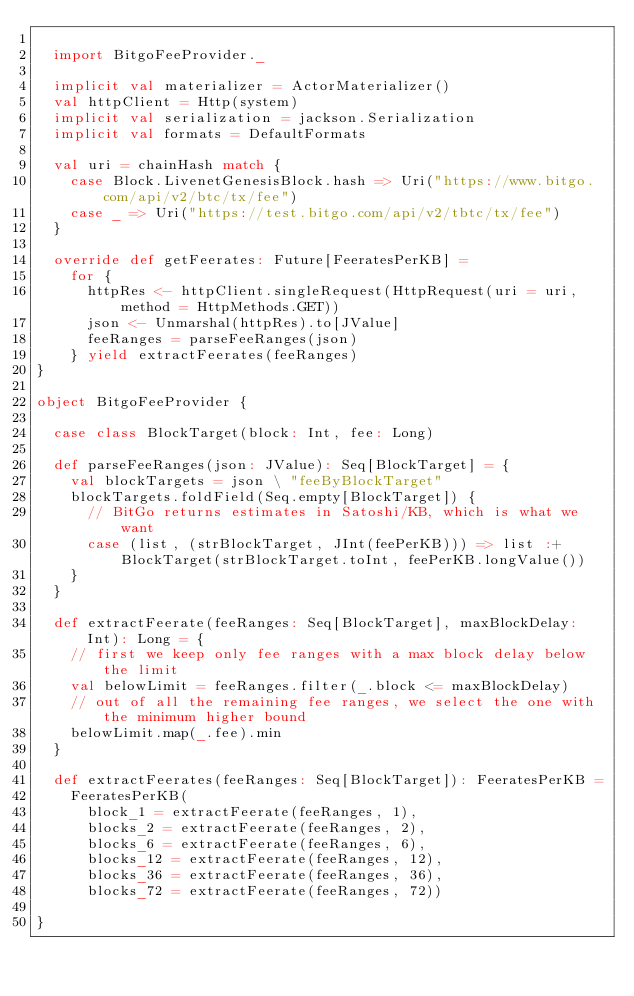<code> <loc_0><loc_0><loc_500><loc_500><_Scala_>
  import BitgoFeeProvider._

  implicit val materializer = ActorMaterializer()
  val httpClient = Http(system)
  implicit val serialization = jackson.Serialization
  implicit val formats = DefaultFormats

  val uri = chainHash match {
    case Block.LivenetGenesisBlock.hash => Uri("https://www.bitgo.com/api/v2/btc/tx/fee")
    case _ => Uri("https://test.bitgo.com/api/v2/tbtc/tx/fee")
  }

  override def getFeerates: Future[FeeratesPerKB] =
    for {
      httpRes <- httpClient.singleRequest(HttpRequest(uri = uri, method = HttpMethods.GET))
      json <- Unmarshal(httpRes).to[JValue]
      feeRanges = parseFeeRanges(json)
    } yield extractFeerates(feeRanges)
}

object BitgoFeeProvider {

  case class BlockTarget(block: Int, fee: Long)

  def parseFeeRanges(json: JValue): Seq[BlockTarget] = {
    val blockTargets = json \ "feeByBlockTarget"
    blockTargets.foldField(Seq.empty[BlockTarget]) {
      // BitGo returns estimates in Satoshi/KB, which is what we want
      case (list, (strBlockTarget, JInt(feePerKB))) => list :+ BlockTarget(strBlockTarget.toInt, feePerKB.longValue())
    }
  }

  def extractFeerate(feeRanges: Seq[BlockTarget], maxBlockDelay: Int): Long = {
    // first we keep only fee ranges with a max block delay below the limit
    val belowLimit = feeRanges.filter(_.block <= maxBlockDelay)
    // out of all the remaining fee ranges, we select the one with the minimum higher bound
    belowLimit.map(_.fee).min
  }

  def extractFeerates(feeRanges: Seq[BlockTarget]): FeeratesPerKB =
    FeeratesPerKB(
      block_1 = extractFeerate(feeRanges, 1),
      blocks_2 = extractFeerate(feeRanges, 2),
      blocks_6 = extractFeerate(feeRanges, 6),
      blocks_12 = extractFeerate(feeRanges, 12),
      blocks_36 = extractFeerate(feeRanges, 36),
      blocks_72 = extractFeerate(feeRanges, 72))

}
</code> 